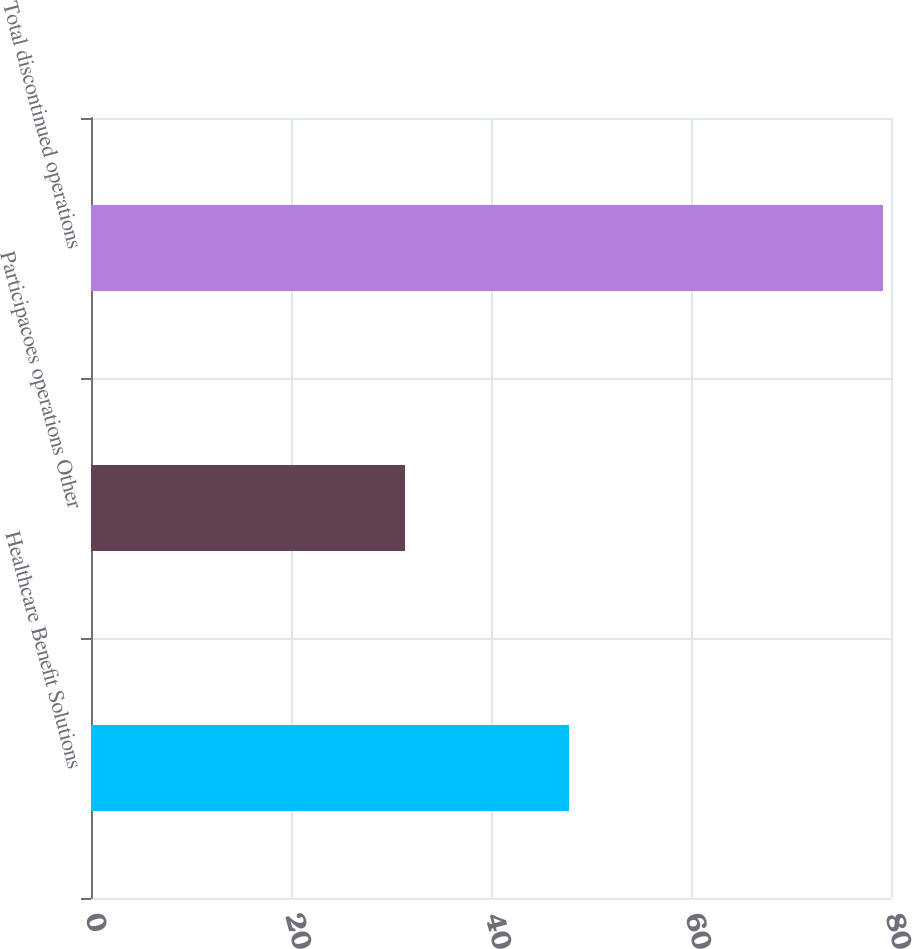Convert chart to OTSL. <chart><loc_0><loc_0><loc_500><loc_500><bar_chart><fcel>Healthcare Benefit Solutions<fcel>Participacoes operations Other<fcel>Total discontinued operations<nl><fcel>47.8<fcel>31.4<fcel>79.2<nl></chart> 